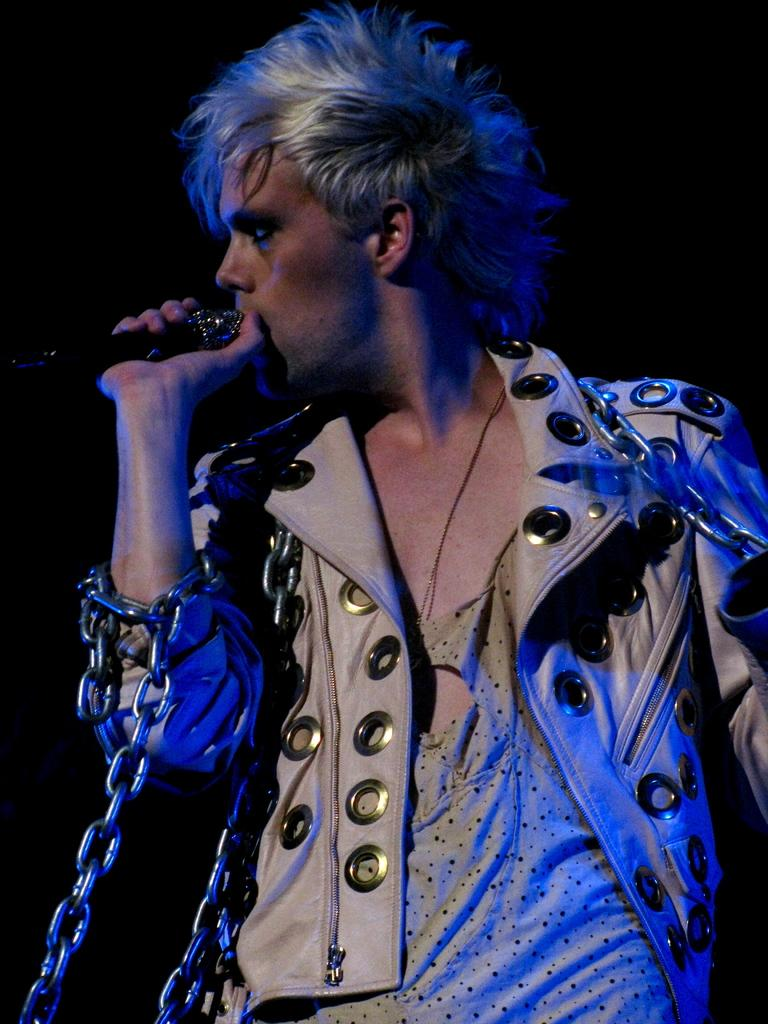What is the main subject of the image? There is a man in the image. What is the man wearing? The man is wearing a white jacket. What is the man holding in his hand? The man has chains in his hand. What is the man doing in the image? The man is singing on a microphone. What is the color of the background in the image? There is a black background in the image. How many fingers does the man have on his left hand in the image? The image does not show the man's fingers, so it is not possible to determine the number of fingers on his left hand. What type of tooth is visible in the man's mouth in the image? There is no tooth visible in the man's mouth in the image. 